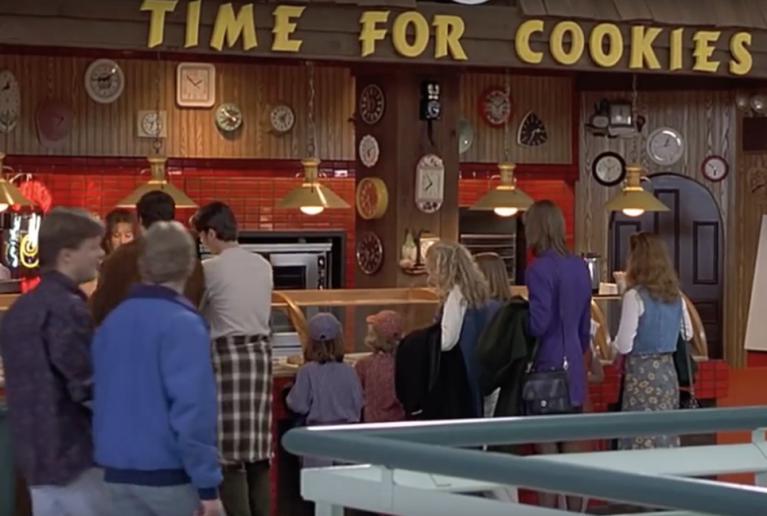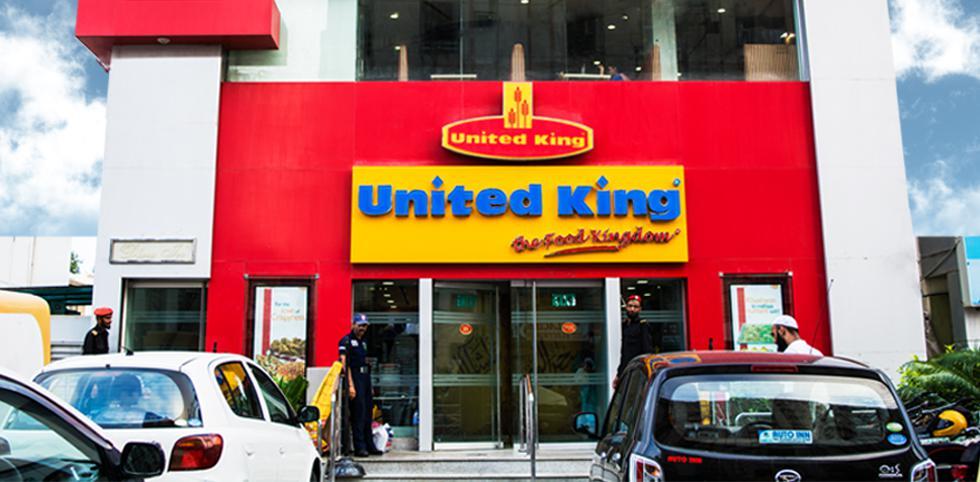The first image is the image on the left, the second image is the image on the right. For the images displayed, is the sentence "There are people in both images." factually correct? Answer yes or no. Yes. The first image is the image on the left, the second image is the image on the right. Assess this claim about the two images: "There are at least three cars in one image.". Correct or not? Answer yes or no. Yes. 